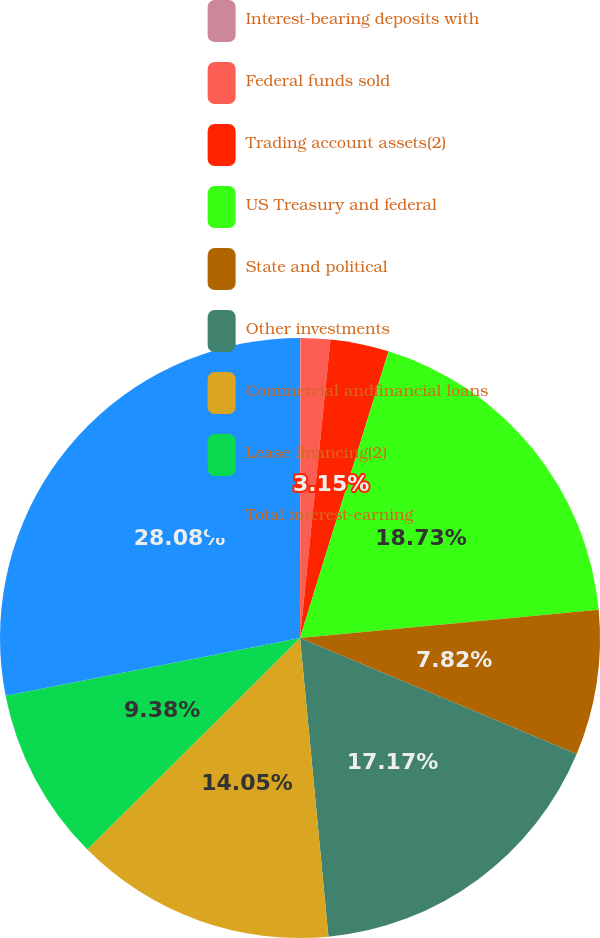<chart> <loc_0><loc_0><loc_500><loc_500><pie_chart><fcel>Interest-bearing deposits with<fcel>Federal funds sold<fcel>Trading account assets(2)<fcel>US Treasury and federal<fcel>State and political<fcel>Other investments<fcel>Commercial andfinancial loans<fcel>Lease financing(2)<fcel>Total interest-earning<nl><fcel>0.03%<fcel>1.59%<fcel>3.15%<fcel>18.73%<fcel>7.82%<fcel>17.17%<fcel>14.05%<fcel>9.38%<fcel>28.08%<nl></chart> 